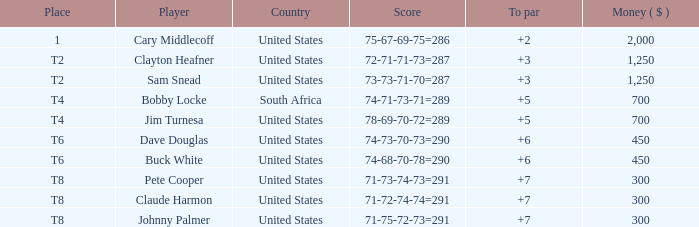What is claude harmon's spot? T8. 